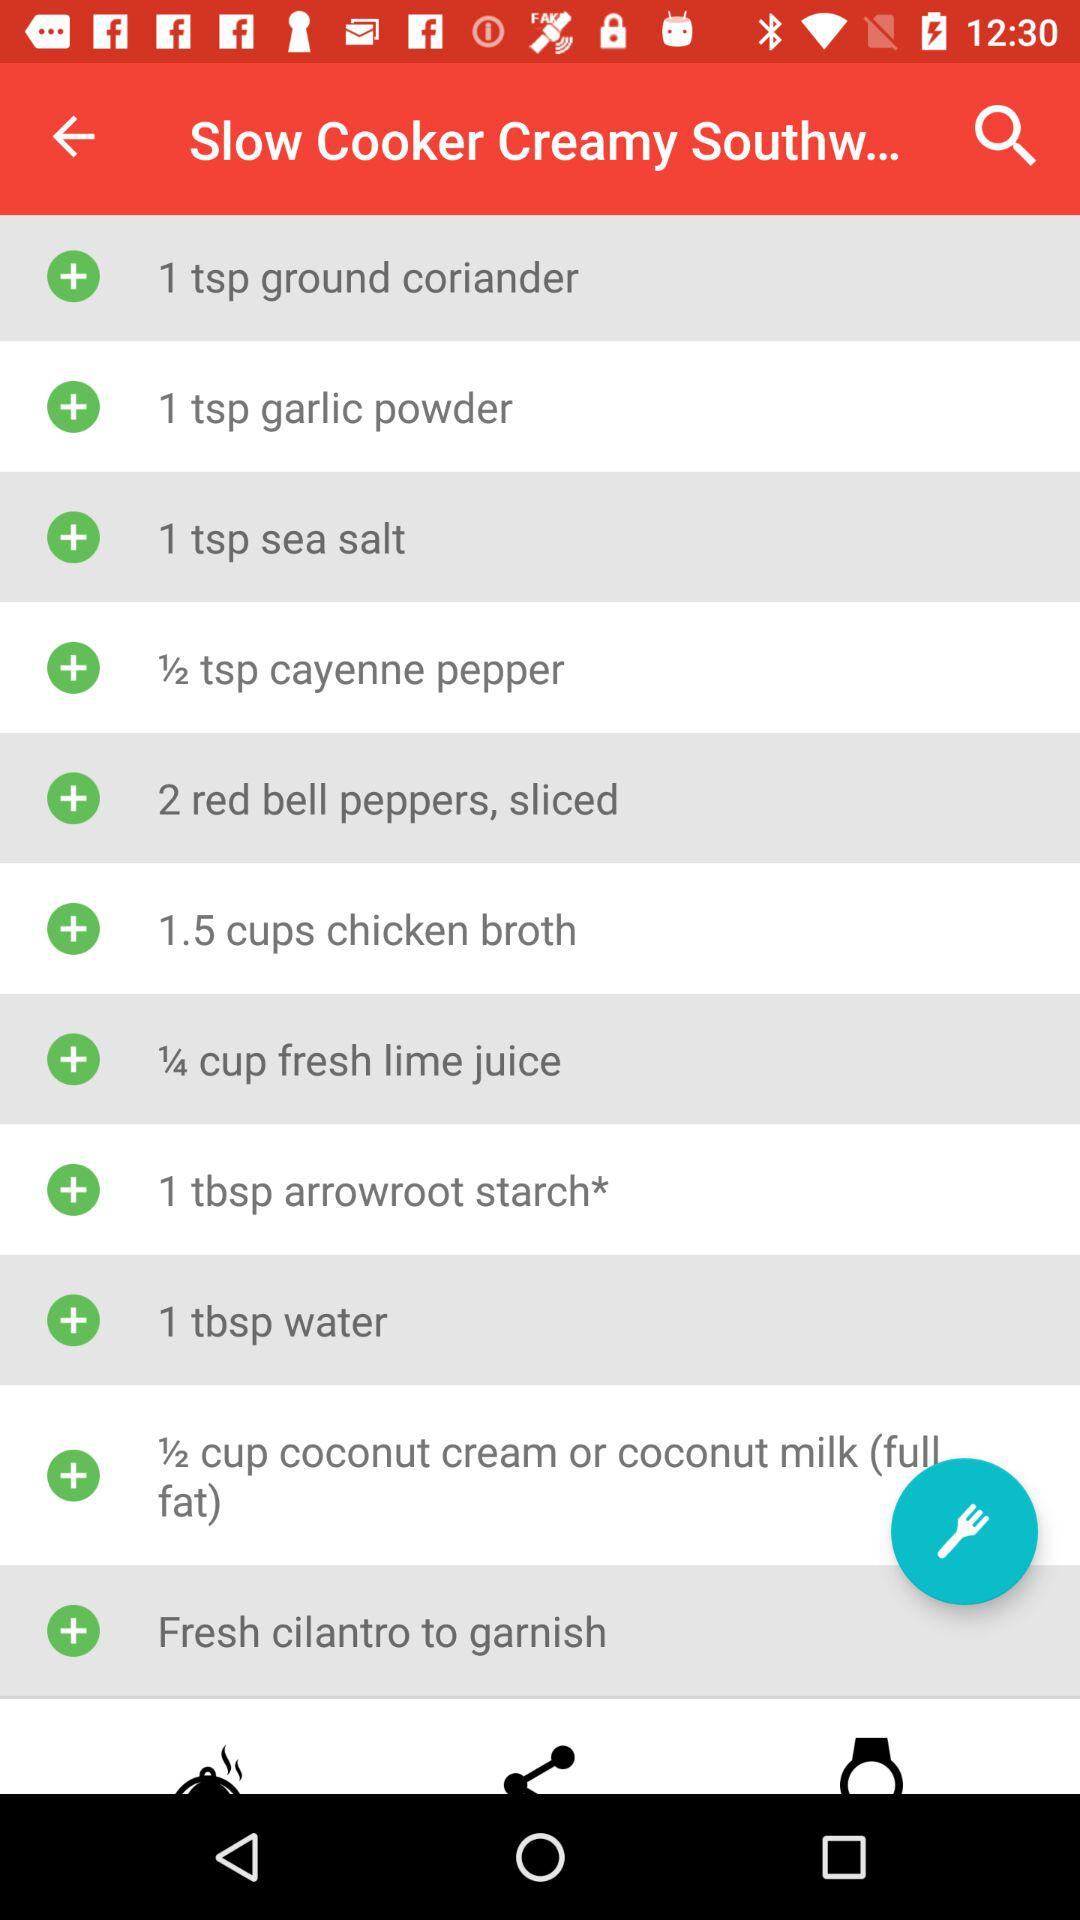How many ingredients are in this recipe?
Answer the question using a single word or phrase. 11 